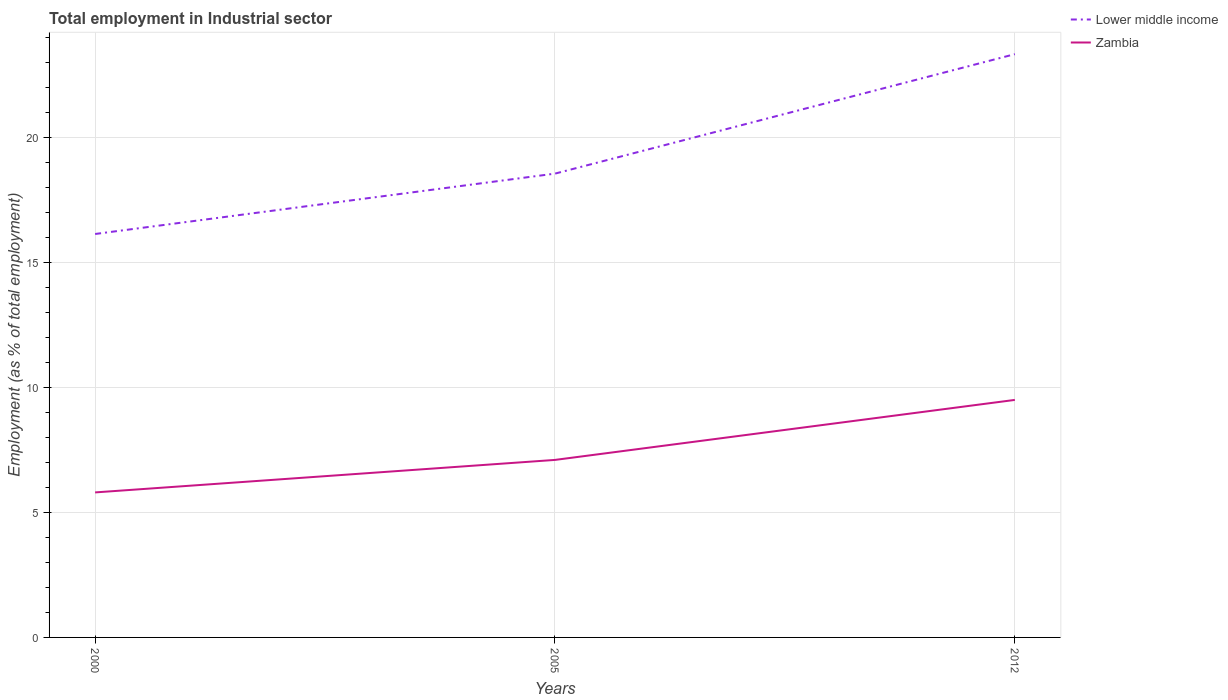How many different coloured lines are there?
Provide a succinct answer. 2. Does the line corresponding to Lower middle income intersect with the line corresponding to Zambia?
Your response must be concise. No. Is the number of lines equal to the number of legend labels?
Provide a succinct answer. Yes. Across all years, what is the maximum employment in industrial sector in Lower middle income?
Provide a short and direct response. 16.14. What is the total employment in industrial sector in Lower middle income in the graph?
Provide a short and direct response. -7.19. What is the difference between the highest and the second highest employment in industrial sector in Lower middle income?
Your answer should be compact. 7.19. How many lines are there?
Make the answer very short. 2. How many years are there in the graph?
Your answer should be very brief. 3. Are the values on the major ticks of Y-axis written in scientific E-notation?
Provide a short and direct response. No. Does the graph contain grids?
Your answer should be compact. Yes. How many legend labels are there?
Provide a short and direct response. 2. How are the legend labels stacked?
Your response must be concise. Vertical. What is the title of the graph?
Offer a very short reply. Total employment in Industrial sector. Does "Canada" appear as one of the legend labels in the graph?
Keep it short and to the point. No. What is the label or title of the X-axis?
Make the answer very short. Years. What is the label or title of the Y-axis?
Ensure brevity in your answer.  Employment (as % of total employment). What is the Employment (as % of total employment) in Lower middle income in 2000?
Your answer should be very brief. 16.14. What is the Employment (as % of total employment) of Zambia in 2000?
Offer a very short reply. 5.8. What is the Employment (as % of total employment) in Lower middle income in 2005?
Your response must be concise. 18.55. What is the Employment (as % of total employment) of Zambia in 2005?
Offer a very short reply. 7.1. What is the Employment (as % of total employment) of Lower middle income in 2012?
Offer a terse response. 23.33. Across all years, what is the maximum Employment (as % of total employment) of Lower middle income?
Provide a short and direct response. 23.33. Across all years, what is the maximum Employment (as % of total employment) in Zambia?
Make the answer very short. 9.5. Across all years, what is the minimum Employment (as % of total employment) in Lower middle income?
Offer a very short reply. 16.14. Across all years, what is the minimum Employment (as % of total employment) of Zambia?
Ensure brevity in your answer.  5.8. What is the total Employment (as % of total employment) in Lower middle income in the graph?
Offer a very short reply. 58.02. What is the total Employment (as % of total employment) in Zambia in the graph?
Give a very brief answer. 22.4. What is the difference between the Employment (as % of total employment) of Lower middle income in 2000 and that in 2005?
Your answer should be very brief. -2.41. What is the difference between the Employment (as % of total employment) of Lower middle income in 2000 and that in 2012?
Provide a short and direct response. -7.19. What is the difference between the Employment (as % of total employment) in Zambia in 2000 and that in 2012?
Make the answer very short. -3.7. What is the difference between the Employment (as % of total employment) of Lower middle income in 2005 and that in 2012?
Your answer should be very brief. -4.78. What is the difference between the Employment (as % of total employment) in Lower middle income in 2000 and the Employment (as % of total employment) in Zambia in 2005?
Provide a succinct answer. 9.04. What is the difference between the Employment (as % of total employment) in Lower middle income in 2000 and the Employment (as % of total employment) in Zambia in 2012?
Provide a short and direct response. 6.64. What is the difference between the Employment (as % of total employment) of Lower middle income in 2005 and the Employment (as % of total employment) of Zambia in 2012?
Provide a short and direct response. 9.05. What is the average Employment (as % of total employment) of Lower middle income per year?
Your answer should be compact. 19.34. What is the average Employment (as % of total employment) in Zambia per year?
Keep it short and to the point. 7.47. In the year 2000, what is the difference between the Employment (as % of total employment) of Lower middle income and Employment (as % of total employment) of Zambia?
Keep it short and to the point. 10.34. In the year 2005, what is the difference between the Employment (as % of total employment) in Lower middle income and Employment (as % of total employment) in Zambia?
Ensure brevity in your answer.  11.45. In the year 2012, what is the difference between the Employment (as % of total employment) of Lower middle income and Employment (as % of total employment) of Zambia?
Your answer should be compact. 13.83. What is the ratio of the Employment (as % of total employment) in Lower middle income in 2000 to that in 2005?
Your response must be concise. 0.87. What is the ratio of the Employment (as % of total employment) of Zambia in 2000 to that in 2005?
Provide a succinct answer. 0.82. What is the ratio of the Employment (as % of total employment) of Lower middle income in 2000 to that in 2012?
Your response must be concise. 0.69. What is the ratio of the Employment (as % of total employment) of Zambia in 2000 to that in 2012?
Your answer should be very brief. 0.61. What is the ratio of the Employment (as % of total employment) of Lower middle income in 2005 to that in 2012?
Ensure brevity in your answer.  0.8. What is the ratio of the Employment (as % of total employment) in Zambia in 2005 to that in 2012?
Your answer should be very brief. 0.75. What is the difference between the highest and the second highest Employment (as % of total employment) of Lower middle income?
Provide a short and direct response. 4.78. What is the difference between the highest and the second highest Employment (as % of total employment) in Zambia?
Your response must be concise. 2.4. What is the difference between the highest and the lowest Employment (as % of total employment) in Lower middle income?
Give a very brief answer. 7.19. What is the difference between the highest and the lowest Employment (as % of total employment) in Zambia?
Your response must be concise. 3.7. 